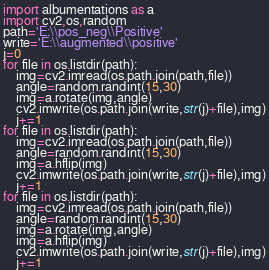<code> <loc_0><loc_0><loc_500><loc_500><_Python_>import albumentations as a
import cv2,os,random
path='E:\\pos_neg\\Positive'
write='E:\\augmented\\positive'
j=0
for file in os.listdir(path):
    img=cv2.imread(os.path.join(path,file))
    angle=random.randint(15,30)
    img=a.rotate(img,angle)
    cv2.imwrite(os.path.join(write,str(j)+file),img)
    j+=1
for file in os.listdir(path):
    img=cv2.imread(os.path.join(path,file))
    angle=random.randint(15,30)
    img=a.hflip(img)
    cv2.imwrite(os.path.join(write,str(j)+file),img)
    j+=1
for file in os.listdir(path):
    img=cv2.imread(os.path.join(path,file))
    angle=random.randint(15,30)
    img=a.rotate(img,angle)
    img=a.hflip(img)
    cv2.imwrite(os.path.join(write,str(j)+file),img)
    j+=1


</code> 